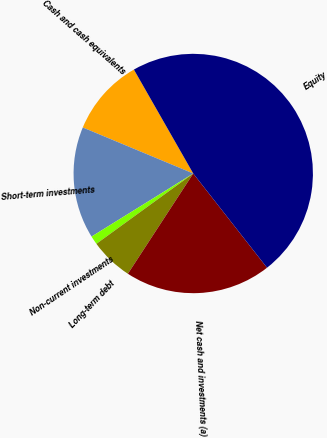Convert chart. <chart><loc_0><loc_0><loc_500><loc_500><pie_chart><fcel>Cash and cash equivalents<fcel>Short-term investments<fcel>Non-current investments<fcel>Long-term debt<fcel>Net cash and investments (a)<fcel>Equity<nl><fcel>10.46%<fcel>15.12%<fcel>1.16%<fcel>5.81%<fcel>19.77%<fcel>47.69%<nl></chart> 